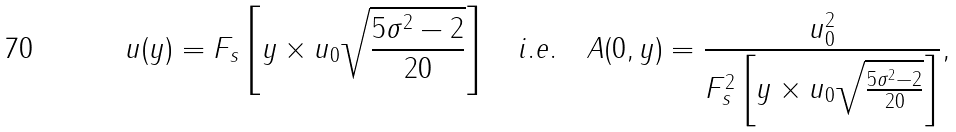Convert formula to latex. <formula><loc_0><loc_0><loc_500><loc_500>u ( y ) = F _ { s } \left [ y \times u _ { 0 } \sqrt { \frac { 5 \sigma ^ { 2 } - 2 } { 2 0 } } \right ] \quad i . e . \quad A ( 0 , y ) = \frac { u _ { 0 } ^ { 2 } } { F _ { s } ^ { 2 } \left [ y \times u _ { 0 } \sqrt { \frac { 5 \sigma ^ { 2 } - 2 } { 2 0 } } \right ] } ,</formula> 